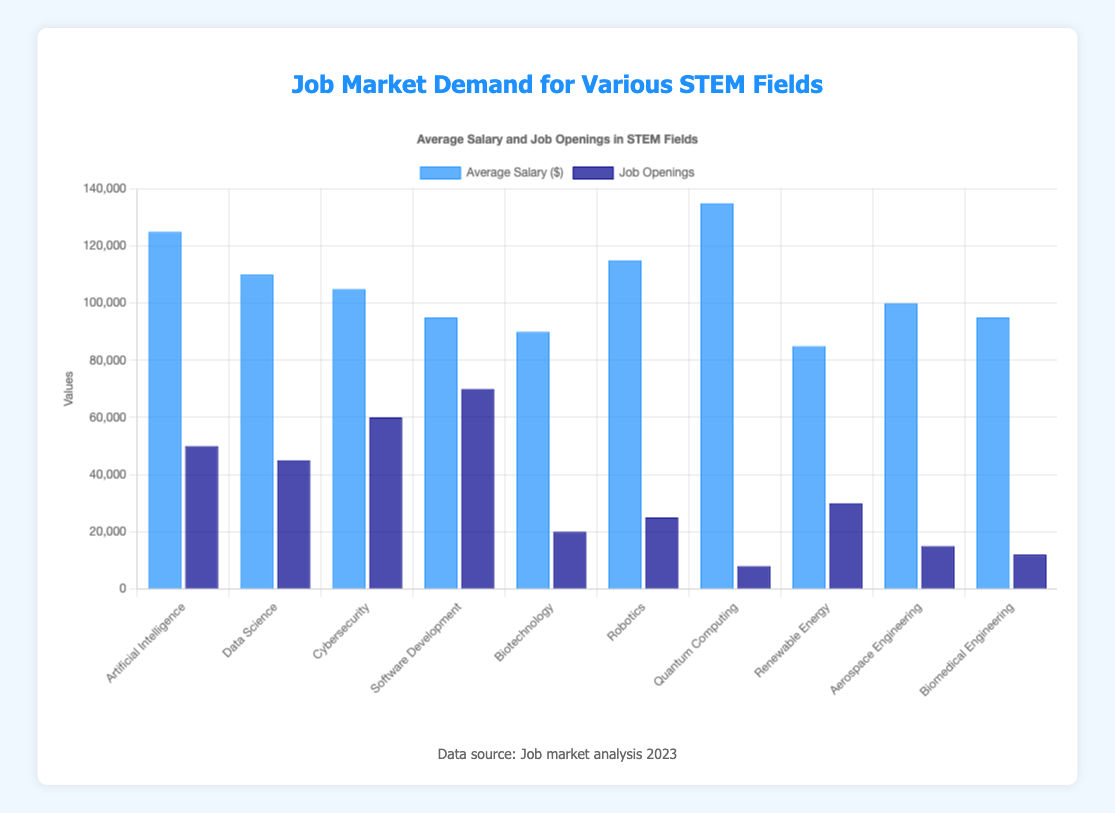Which field has the highest average salary? The field with the highest blue bar represents the highest average salary on the chart.
Answer: Quantum Computing Which field has the most job openings? The field with the tallest dark blue bar represents the most job openings on the chart.
Answer: Software Development How much more is the average salary in Artificial Intelligence compared to Software Development? Subtract the average salary of Software Development from the average salary of Artificial Intelligence: 125,000 - 95,000.
Answer: 30,000 How many job openings are there in Cybersecurity and Data Science combined? Add the job openings of Cybersecurity and Data Science: 60,000 + 45,000.
Answer: 105,000 Is the average salary of Robotics higher than that of Data Science? Compare the heights of the respective blue bars for Robotics and Data Science.
Answer: Yes Which field has the least number of job openings? The field with the shortest dark blue bar represents the least job openings on the chart.
Answer: Quantum Computing What is the average salary of the fields with over 50,000 job openings? Average salaries are: Data Science (110,000), Cybersecurity (105,000), and Software Development (95,000). Sum = 110,000 + 105,000 + 95,000 = 310,000. Average = 310,000 / 3.
Answer: 103,333 Compare the job openings in Biomedical Engineering and Aerospace Engineering. Which is higher? Look at the darker blue bars. Aerospace Engineering has 15,000, while Biomedical Engineering has 12,000.
Answer: Aerospace Engineering What is the difference in average salary between Quantum Computing and Renewable Energy? Subtract the average salary of Renewable Energy from Quantum Computing: 135,000 - 85,000.
Answer: 50,000 Which field has approximately twice as many job openings as Quantum Computing? Identify the field whose dark blue bar height is roughly double that of Quantum Computing (8,000 job openings). Renewable Energy has 30,000 job openings, closest in ratio.
Answer: Renewable Energy 